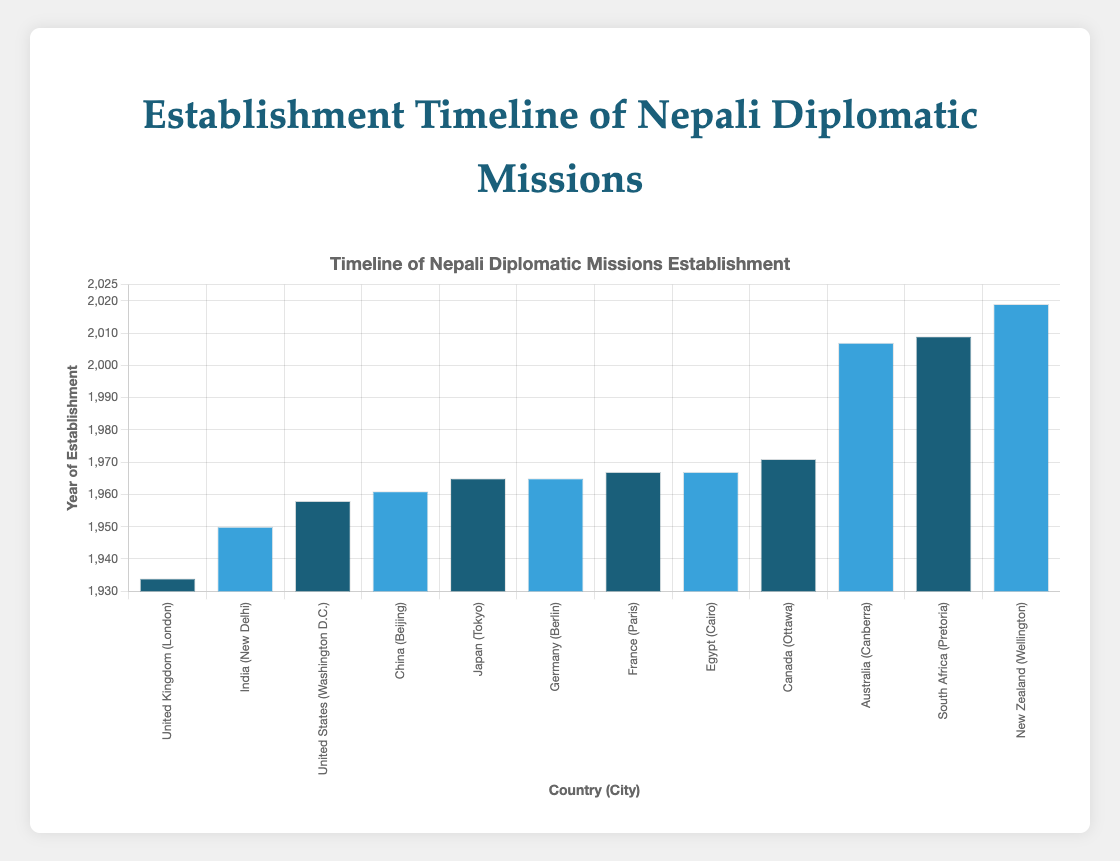How many diplomatic missions were established by Nepal in the 1960s? The figure shows the year of establishment for each diplomatic mission. Examine the years for each bar and count the ones that fall between 1960 and 1969. The missions in China (1961), Japan (1965), Germany (1965), France (1967), and Egypt (1967) were established in the 1960s.
Answer: 5 What is the difference in the year of establishment between the oldest and the newest diplomatic missions? The figure shows the timeline of establishment years. The oldest mission is in the United Kingdom (1934) and the newest mission is in New Zealand (2019). The difference is calculated as 2019 - 1934.
Answer: 85 years Which continent had the highest number of diplomatic missions established by Nepal? To answer this question, count the number of bars for each continent displayed in the figure. Asia has missions in India (1950), China (1961), and Japan (1965). Europe has missions in the United Kingdom (1934), Germany (1965), and France (1967). North America has missions in the United States (1958) and Canada (1971). Oceania has missions in Australia (2007) and New Zealand (2019). Africa has missions in South Africa (2009) and Egypt (1967). The continents with the highest number of missions are Asia and Europe, each with 3 missions.
Answer: Asia and Europe What is the median year of establishment for diplomatic missions in Europe? Arrange the years of establishment for the European missions in ascending order: 1934 (United Kingdom), 1965 (Germany), and 1967 (France). The median is the middle value in this ordered list.
Answer: 1965 How many diplomatic missions were set up after the year 2000? Look at the bars representing years of establishment and count the ones after the year 2000: Australia (2007), South Africa (2009), and New Zealand (2019).
Answer: 3 Which country in Asia had the earliest diplomatic mission established, and in which year? For the Asian countries listed, observe the years of establishment shown in the figure. India (1950) is the earliest among India, China (1961), and Japan (1965).
Answer: India, 1950 Which countries have diplomatic missions with establishment years in the 1970s? Look at the years of establishment and identify those that fall between 1970 and 1979. The figure shows Canada with the establishment year of 1971.
Answer: Canada Which diplomatic mission was established first, the one in Egypt or the one in Germany, and by how many years? Compare the establishment years of Egypt (1967) and Germany (1965). Calculate the difference: 1967 - 1965.
Answer: Germany, 2 years Identify the continent with the most recent diplomatic mission established and name the country. The most recent establishment is in New Zealand (2019). This country is in the continent of Oceania.
Answer: Oceania, New Zealand Are there any continents with only one diplomatic mission established by Nepal? To answer this, count the number of missions on each continent. Oceania has missions in Australia (2007) and New Zealand (2019), while Africa has missions in South Africa (2009) and Egypt (1967). All continents have more than one mission.
Answer: No 